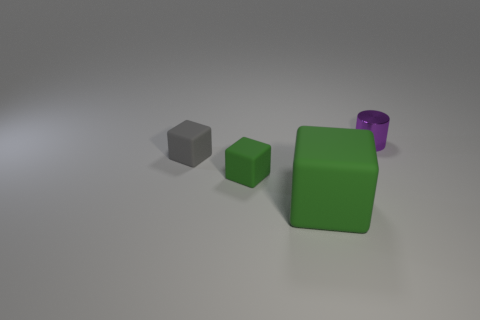How many green blocks must be subtracted to get 1 green blocks? 1 Subtract all blocks. How many objects are left? 1 Subtract 1 cylinders. How many cylinders are left? 0 Subtract all red cylinders. Subtract all brown spheres. How many cylinders are left? 1 Subtract all red cylinders. How many gray blocks are left? 1 Subtract all cubes. Subtract all large red metal cubes. How many objects are left? 1 Add 1 tiny cylinders. How many tiny cylinders are left? 2 Add 3 big rubber cubes. How many big rubber cubes exist? 4 Add 2 big objects. How many objects exist? 6 Subtract all gray cubes. How many cubes are left? 2 